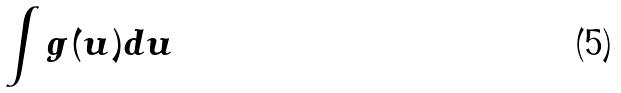<formula> <loc_0><loc_0><loc_500><loc_500>\int g ( u ) d u</formula> 